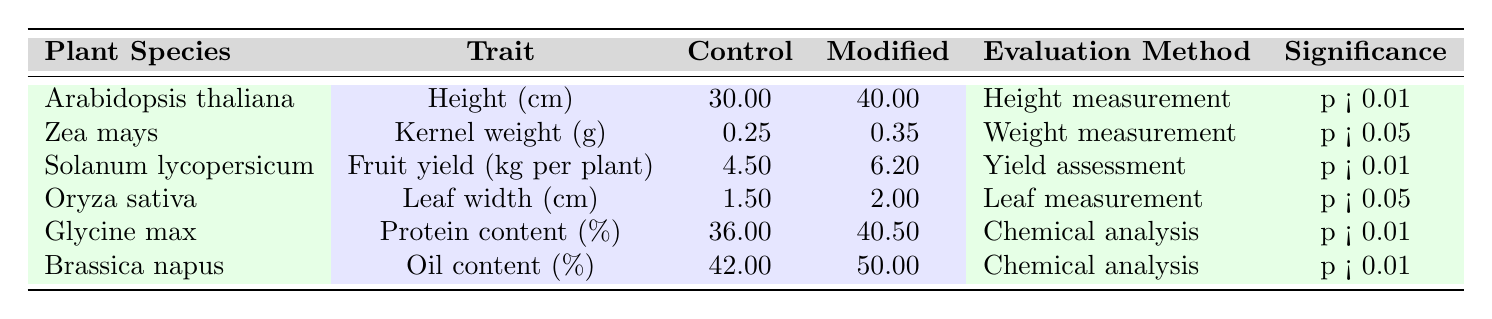What is the control value for the height of Arabidopsis thaliana? The table lists Arabidopsis thaliana under the plant species column and shows its control value in the third column, which is 30.00 cm.
Answer: 30.00 cm Which trait shows the highest significance level? Two traits show significance levels of p < 0.01: Height of Arabidopsis thaliana, Fruit yield of Solanum lycopersicum, Protein content of Glycine max, and Oil content of Brassica napus. The highest significance level indicated is p < 0.01, which is the same for multiple traits.
Answer: p < 0.01 What is the difference in kernel weight between Zea mays control and modified values? The control value for kernel weight in Zea mays is 0.25 g and the modified value is 0.35 g. To find the difference, we subtract the control value from the modified value: 0.35 - 0.25 = 0.10.
Answer: 0.10 g Is the fruit yield for Solanum lycopersicum in the modified state greater than 5 kg per plant? The modified value for Solanum lycopersicum is 6.2 kg per plant, which is greater than 5 kg. Thus, the statement is true.
Answer: Yes What is the average protein content for Glycine max and oil content for Brassica napus? The protein content for Glycine max is 40.5% and the oil content for Brassica napus is 50.0%. To find the average, we sum these two values: 40.5 + 50.0 = 90.5, then divide by 2: 90.5 / 2 = 45.25.
Answer: 45.25% What are the evaluation methods used for the traits of Oryza sativa and Zea mays? According to the table, Oryza sativa's evaluation method is "Leaf measurement" and Zea mays' evaluation method is "Weight measurement". These can be directly referred from the respective rows in the table.
Answer: Leaf measurement and Weight measurement Which plant species has an increase in height after genetic modification? The table indicates that Arabidopsis thaliana had a control height of 30 cm and a modified height of 40 cm, which is an increase. Therefore, the plant species is Arabidopsis thaliana.
Answer: Arabidopsis thaliana What is the leaf width difference between control and modified for Oryza sativa? For Oryza sativa, the control value is 1.5 cm and the modified value is 2.0 cm. The difference is calculated as: 2.0 - 1.5 = 0.5 cm.
Answer: 0.5 cm Is the control value for oil content in Brassica napus less than 45%? The control value for oil content in Brassica napus is 42%, which is indeed less than 45%. Hence, this statement is true.
Answer: Yes 